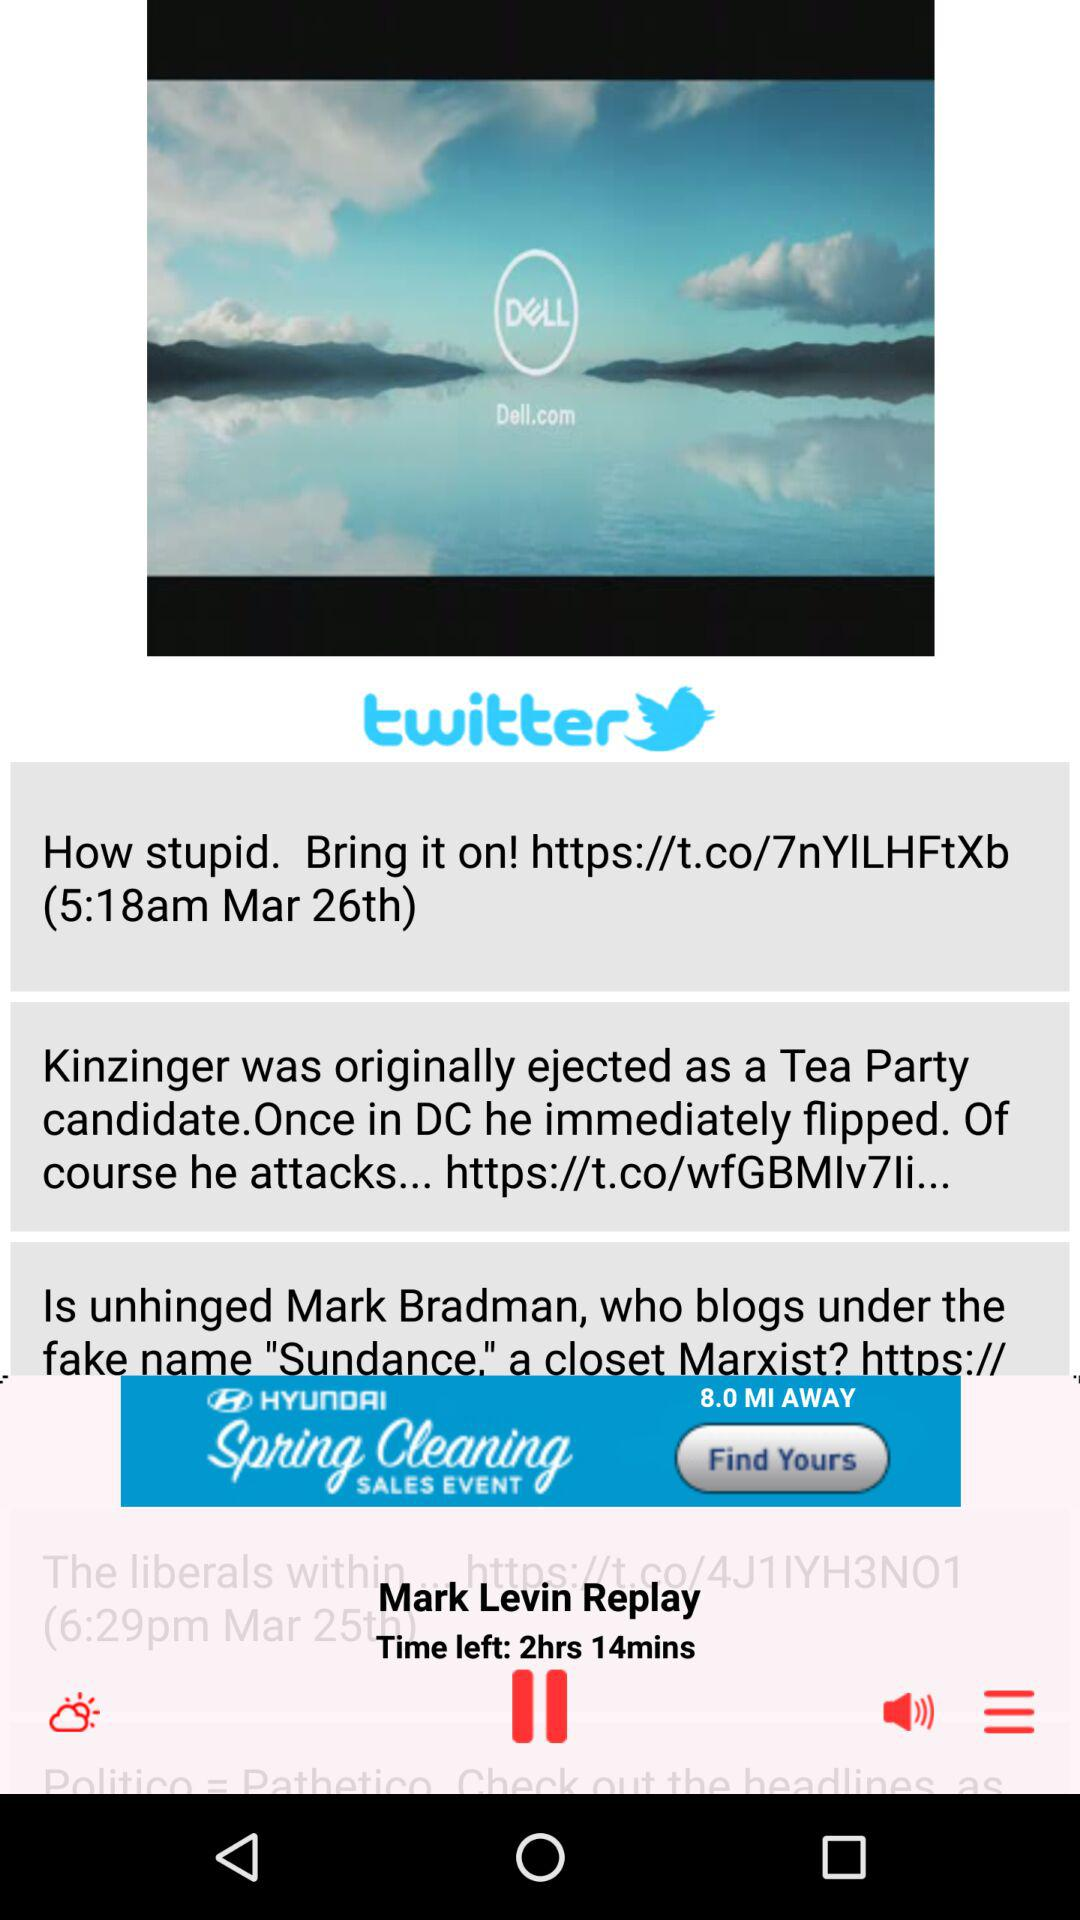What is the time? The times are 5:18 a.m. and 6:29 p.m. 